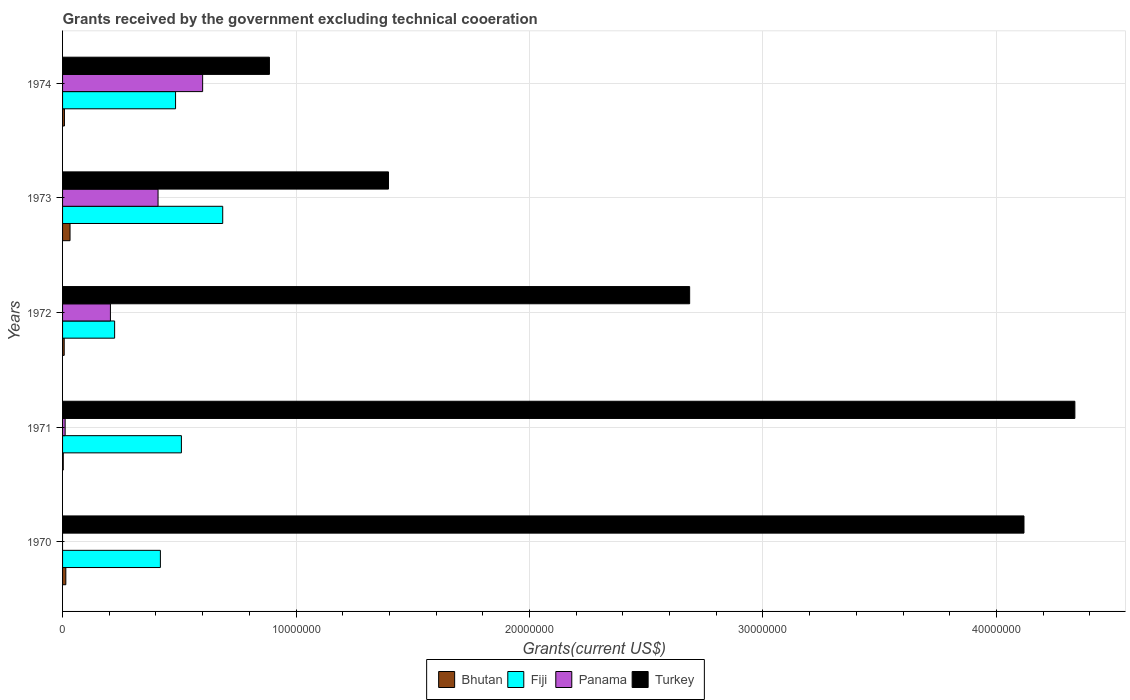How many different coloured bars are there?
Make the answer very short. 4. Are the number of bars on each tick of the Y-axis equal?
Offer a terse response. No. What is the label of the 3rd group of bars from the top?
Keep it short and to the point. 1972. What is the total grants received by the government in Panama in 1973?
Ensure brevity in your answer.  4.09e+06. Across all years, what is the maximum total grants received by the government in Bhutan?
Offer a very short reply. 3.20e+05. Across all years, what is the minimum total grants received by the government in Turkey?
Offer a very short reply. 8.86e+06. In which year was the total grants received by the government in Turkey maximum?
Your answer should be very brief. 1971. What is the total total grants received by the government in Fiji in the graph?
Your answer should be compact. 2.32e+07. What is the difference between the total grants received by the government in Turkey in 1970 and that in 1973?
Your answer should be very brief. 2.72e+07. What is the difference between the total grants received by the government in Turkey in 1970 and the total grants received by the government in Panama in 1973?
Provide a succinct answer. 3.71e+07. What is the average total grants received by the government in Turkey per year?
Give a very brief answer. 2.68e+07. In the year 1971, what is the difference between the total grants received by the government in Bhutan and total grants received by the government in Panama?
Your answer should be very brief. -8.00e+04. What is the ratio of the total grants received by the government in Turkey in 1970 to that in 1972?
Your answer should be compact. 1.53. Is the total grants received by the government in Fiji in 1973 less than that in 1974?
Offer a terse response. No. What is the difference between the highest and the second highest total grants received by the government in Panama?
Offer a terse response. 1.91e+06. What is the difference between the highest and the lowest total grants received by the government in Turkey?
Provide a succinct answer. 3.45e+07. Are all the bars in the graph horizontal?
Provide a succinct answer. Yes. What is the difference between two consecutive major ticks on the X-axis?
Your answer should be compact. 1.00e+07. How many legend labels are there?
Give a very brief answer. 4. How are the legend labels stacked?
Make the answer very short. Horizontal. What is the title of the graph?
Your response must be concise. Grants received by the government excluding technical cooeration. Does "Benin" appear as one of the legend labels in the graph?
Your answer should be compact. No. What is the label or title of the X-axis?
Make the answer very short. Grants(current US$). What is the label or title of the Y-axis?
Make the answer very short. Years. What is the Grants(current US$) in Fiji in 1970?
Your answer should be compact. 4.19e+06. What is the Grants(current US$) of Panama in 1970?
Keep it short and to the point. 0. What is the Grants(current US$) of Turkey in 1970?
Offer a terse response. 4.12e+07. What is the Grants(current US$) of Fiji in 1971?
Ensure brevity in your answer.  5.09e+06. What is the Grants(current US$) in Panama in 1971?
Keep it short and to the point. 1.10e+05. What is the Grants(current US$) in Turkey in 1971?
Your answer should be compact. 4.34e+07. What is the Grants(current US$) of Fiji in 1972?
Ensure brevity in your answer.  2.23e+06. What is the Grants(current US$) of Panama in 1972?
Give a very brief answer. 2.05e+06. What is the Grants(current US$) of Turkey in 1972?
Make the answer very short. 2.69e+07. What is the Grants(current US$) of Bhutan in 1973?
Keep it short and to the point. 3.20e+05. What is the Grants(current US$) of Fiji in 1973?
Ensure brevity in your answer.  6.86e+06. What is the Grants(current US$) of Panama in 1973?
Your answer should be compact. 4.09e+06. What is the Grants(current US$) in Turkey in 1973?
Offer a very short reply. 1.40e+07. What is the Grants(current US$) in Bhutan in 1974?
Provide a succinct answer. 8.00e+04. What is the Grants(current US$) of Fiji in 1974?
Give a very brief answer. 4.84e+06. What is the Grants(current US$) of Panama in 1974?
Give a very brief answer. 6.00e+06. What is the Grants(current US$) of Turkey in 1974?
Make the answer very short. 8.86e+06. Across all years, what is the maximum Grants(current US$) of Fiji?
Offer a very short reply. 6.86e+06. Across all years, what is the maximum Grants(current US$) of Panama?
Offer a very short reply. 6.00e+06. Across all years, what is the maximum Grants(current US$) of Turkey?
Keep it short and to the point. 4.34e+07. Across all years, what is the minimum Grants(current US$) in Fiji?
Give a very brief answer. 2.23e+06. Across all years, what is the minimum Grants(current US$) of Turkey?
Your answer should be compact. 8.86e+06. What is the total Grants(current US$) in Bhutan in the graph?
Keep it short and to the point. 6.40e+05. What is the total Grants(current US$) of Fiji in the graph?
Keep it short and to the point. 2.32e+07. What is the total Grants(current US$) of Panama in the graph?
Your response must be concise. 1.22e+07. What is the total Grants(current US$) in Turkey in the graph?
Provide a short and direct response. 1.34e+08. What is the difference between the Grants(current US$) in Fiji in 1970 and that in 1971?
Offer a terse response. -9.00e+05. What is the difference between the Grants(current US$) of Turkey in 1970 and that in 1971?
Give a very brief answer. -2.18e+06. What is the difference between the Grants(current US$) of Fiji in 1970 and that in 1972?
Your answer should be very brief. 1.96e+06. What is the difference between the Grants(current US$) of Turkey in 1970 and that in 1972?
Provide a succinct answer. 1.43e+07. What is the difference between the Grants(current US$) of Bhutan in 1970 and that in 1973?
Provide a short and direct response. -1.80e+05. What is the difference between the Grants(current US$) in Fiji in 1970 and that in 1973?
Offer a terse response. -2.67e+06. What is the difference between the Grants(current US$) in Turkey in 1970 and that in 1973?
Keep it short and to the point. 2.72e+07. What is the difference between the Grants(current US$) in Fiji in 1970 and that in 1974?
Make the answer very short. -6.50e+05. What is the difference between the Grants(current US$) in Turkey in 1970 and that in 1974?
Keep it short and to the point. 3.23e+07. What is the difference between the Grants(current US$) in Fiji in 1971 and that in 1972?
Provide a short and direct response. 2.86e+06. What is the difference between the Grants(current US$) of Panama in 1971 and that in 1972?
Keep it short and to the point. -1.94e+06. What is the difference between the Grants(current US$) in Turkey in 1971 and that in 1972?
Ensure brevity in your answer.  1.65e+07. What is the difference between the Grants(current US$) of Bhutan in 1971 and that in 1973?
Ensure brevity in your answer.  -2.90e+05. What is the difference between the Grants(current US$) of Fiji in 1971 and that in 1973?
Make the answer very short. -1.77e+06. What is the difference between the Grants(current US$) in Panama in 1971 and that in 1973?
Ensure brevity in your answer.  -3.98e+06. What is the difference between the Grants(current US$) in Turkey in 1971 and that in 1973?
Ensure brevity in your answer.  2.94e+07. What is the difference between the Grants(current US$) in Bhutan in 1971 and that in 1974?
Ensure brevity in your answer.  -5.00e+04. What is the difference between the Grants(current US$) of Panama in 1971 and that in 1974?
Ensure brevity in your answer.  -5.89e+06. What is the difference between the Grants(current US$) in Turkey in 1971 and that in 1974?
Your answer should be very brief. 3.45e+07. What is the difference between the Grants(current US$) of Bhutan in 1972 and that in 1973?
Your response must be concise. -2.50e+05. What is the difference between the Grants(current US$) of Fiji in 1972 and that in 1973?
Your response must be concise. -4.63e+06. What is the difference between the Grants(current US$) of Panama in 1972 and that in 1973?
Your answer should be compact. -2.04e+06. What is the difference between the Grants(current US$) of Turkey in 1972 and that in 1973?
Offer a very short reply. 1.29e+07. What is the difference between the Grants(current US$) in Bhutan in 1972 and that in 1974?
Your response must be concise. -10000. What is the difference between the Grants(current US$) of Fiji in 1972 and that in 1974?
Offer a very short reply. -2.61e+06. What is the difference between the Grants(current US$) of Panama in 1972 and that in 1974?
Offer a very short reply. -3.95e+06. What is the difference between the Grants(current US$) of Turkey in 1972 and that in 1974?
Keep it short and to the point. 1.80e+07. What is the difference between the Grants(current US$) in Fiji in 1973 and that in 1974?
Give a very brief answer. 2.02e+06. What is the difference between the Grants(current US$) of Panama in 1973 and that in 1974?
Make the answer very short. -1.91e+06. What is the difference between the Grants(current US$) of Turkey in 1973 and that in 1974?
Make the answer very short. 5.10e+06. What is the difference between the Grants(current US$) of Bhutan in 1970 and the Grants(current US$) of Fiji in 1971?
Offer a very short reply. -4.95e+06. What is the difference between the Grants(current US$) of Bhutan in 1970 and the Grants(current US$) of Turkey in 1971?
Offer a terse response. -4.32e+07. What is the difference between the Grants(current US$) of Fiji in 1970 and the Grants(current US$) of Panama in 1971?
Provide a short and direct response. 4.08e+06. What is the difference between the Grants(current US$) in Fiji in 1970 and the Grants(current US$) in Turkey in 1971?
Your answer should be compact. -3.92e+07. What is the difference between the Grants(current US$) of Bhutan in 1970 and the Grants(current US$) of Fiji in 1972?
Provide a short and direct response. -2.09e+06. What is the difference between the Grants(current US$) of Bhutan in 1970 and the Grants(current US$) of Panama in 1972?
Provide a succinct answer. -1.91e+06. What is the difference between the Grants(current US$) of Bhutan in 1970 and the Grants(current US$) of Turkey in 1972?
Offer a terse response. -2.67e+07. What is the difference between the Grants(current US$) in Fiji in 1970 and the Grants(current US$) in Panama in 1972?
Your answer should be very brief. 2.14e+06. What is the difference between the Grants(current US$) in Fiji in 1970 and the Grants(current US$) in Turkey in 1972?
Your response must be concise. -2.27e+07. What is the difference between the Grants(current US$) in Bhutan in 1970 and the Grants(current US$) in Fiji in 1973?
Give a very brief answer. -6.72e+06. What is the difference between the Grants(current US$) of Bhutan in 1970 and the Grants(current US$) of Panama in 1973?
Your answer should be very brief. -3.95e+06. What is the difference between the Grants(current US$) in Bhutan in 1970 and the Grants(current US$) in Turkey in 1973?
Provide a succinct answer. -1.38e+07. What is the difference between the Grants(current US$) in Fiji in 1970 and the Grants(current US$) in Panama in 1973?
Make the answer very short. 1.00e+05. What is the difference between the Grants(current US$) in Fiji in 1970 and the Grants(current US$) in Turkey in 1973?
Ensure brevity in your answer.  -9.77e+06. What is the difference between the Grants(current US$) in Bhutan in 1970 and the Grants(current US$) in Fiji in 1974?
Provide a short and direct response. -4.70e+06. What is the difference between the Grants(current US$) in Bhutan in 1970 and the Grants(current US$) in Panama in 1974?
Give a very brief answer. -5.86e+06. What is the difference between the Grants(current US$) in Bhutan in 1970 and the Grants(current US$) in Turkey in 1974?
Your answer should be compact. -8.72e+06. What is the difference between the Grants(current US$) in Fiji in 1970 and the Grants(current US$) in Panama in 1974?
Provide a succinct answer. -1.81e+06. What is the difference between the Grants(current US$) in Fiji in 1970 and the Grants(current US$) in Turkey in 1974?
Ensure brevity in your answer.  -4.67e+06. What is the difference between the Grants(current US$) in Bhutan in 1971 and the Grants(current US$) in Fiji in 1972?
Your answer should be very brief. -2.20e+06. What is the difference between the Grants(current US$) in Bhutan in 1971 and the Grants(current US$) in Panama in 1972?
Make the answer very short. -2.02e+06. What is the difference between the Grants(current US$) in Bhutan in 1971 and the Grants(current US$) in Turkey in 1972?
Make the answer very short. -2.68e+07. What is the difference between the Grants(current US$) of Fiji in 1971 and the Grants(current US$) of Panama in 1972?
Make the answer very short. 3.04e+06. What is the difference between the Grants(current US$) of Fiji in 1971 and the Grants(current US$) of Turkey in 1972?
Your answer should be compact. -2.18e+07. What is the difference between the Grants(current US$) of Panama in 1971 and the Grants(current US$) of Turkey in 1972?
Your answer should be compact. -2.68e+07. What is the difference between the Grants(current US$) in Bhutan in 1971 and the Grants(current US$) in Fiji in 1973?
Give a very brief answer. -6.83e+06. What is the difference between the Grants(current US$) in Bhutan in 1971 and the Grants(current US$) in Panama in 1973?
Offer a terse response. -4.06e+06. What is the difference between the Grants(current US$) of Bhutan in 1971 and the Grants(current US$) of Turkey in 1973?
Give a very brief answer. -1.39e+07. What is the difference between the Grants(current US$) of Fiji in 1971 and the Grants(current US$) of Panama in 1973?
Make the answer very short. 1.00e+06. What is the difference between the Grants(current US$) in Fiji in 1971 and the Grants(current US$) in Turkey in 1973?
Make the answer very short. -8.87e+06. What is the difference between the Grants(current US$) of Panama in 1971 and the Grants(current US$) of Turkey in 1973?
Give a very brief answer. -1.38e+07. What is the difference between the Grants(current US$) of Bhutan in 1971 and the Grants(current US$) of Fiji in 1974?
Your response must be concise. -4.81e+06. What is the difference between the Grants(current US$) of Bhutan in 1971 and the Grants(current US$) of Panama in 1974?
Offer a very short reply. -5.97e+06. What is the difference between the Grants(current US$) of Bhutan in 1971 and the Grants(current US$) of Turkey in 1974?
Provide a succinct answer. -8.83e+06. What is the difference between the Grants(current US$) in Fiji in 1971 and the Grants(current US$) in Panama in 1974?
Offer a terse response. -9.10e+05. What is the difference between the Grants(current US$) in Fiji in 1971 and the Grants(current US$) in Turkey in 1974?
Your answer should be very brief. -3.77e+06. What is the difference between the Grants(current US$) in Panama in 1971 and the Grants(current US$) in Turkey in 1974?
Make the answer very short. -8.75e+06. What is the difference between the Grants(current US$) in Bhutan in 1972 and the Grants(current US$) in Fiji in 1973?
Provide a short and direct response. -6.79e+06. What is the difference between the Grants(current US$) of Bhutan in 1972 and the Grants(current US$) of Panama in 1973?
Provide a short and direct response. -4.02e+06. What is the difference between the Grants(current US$) in Bhutan in 1972 and the Grants(current US$) in Turkey in 1973?
Your answer should be very brief. -1.39e+07. What is the difference between the Grants(current US$) in Fiji in 1972 and the Grants(current US$) in Panama in 1973?
Give a very brief answer. -1.86e+06. What is the difference between the Grants(current US$) in Fiji in 1972 and the Grants(current US$) in Turkey in 1973?
Provide a succinct answer. -1.17e+07. What is the difference between the Grants(current US$) of Panama in 1972 and the Grants(current US$) of Turkey in 1973?
Provide a short and direct response. -1.19e+07. What is the difference between the Grants(current US$) of Bhutan in 1972 and the Grants(current US$) of Fiji in 1974?
Provide a succinct answer. -4.77e+06. What is the difference between the Grants(current US$) of Bhutan in 1972 and the Grants(current US$) of Panama in 1974?
Offer a very short reply. -5.93e+06. What is the difference between the Grants(current US$) in Bhutan in 1972 and the Grants(current US$) in Turkey in 1974?
Offer a very short reply. -8.79e+06. What is the difference between the Grants(current US$) in Fiji in 1972 and the Grants(current US$) in Panama in 1974?
Give a very brief answer. -3.77e+06. What is the difference between the Grants(current US$) of Fiji in 1972 and the Grants(current US$) of Turkey in 1974?
Your response must be concise. -6.63e+06. What is the difference between the Grants(current US$) in Panama in 1972 and the Grants(current US$) in Turkey in 1974?
Ensure brevity in your answer.  -6.81e+06. What is the difference between the Grants(current US$) in Bhutan in 1973 and the Grants(current US$) in Fiji in 1974?
Keep it short and to the point. -4.52e+06. What is the difference between the Grants(current US$) of Bhutan in 1973 and the Grants(current US$) of Panama in 1974?
Offer a very short reply. -5.68e+06. What is the difference between the Grants(current US$) in Bhutan in 1973 and the Grants(current US$) in Turkey in 1974?
Make the answer very short. -8.54e+06. What is the difference between the Grants(current US$) in Fiji in 1973 and the Grants(current US$) in Panama in 1974?
Your answer should be very brief. 8.60e+05. What is the difference between the Grants(current US$) in Fiji in 1973 and the Grants(current US$) in Turkey in 1974?
Your answer should be compact. -2.00e+06. What is the difference between the Grants(current US$) of Panama in 1973 and the Grants(current US$) of Turkey in 1974?
Your answer should be compact. -4.77e+06. What is the average Grants(current US$) in Bhutan per year?
Ensure brevity in your answer.  1.28e+05. What is the average Grants(current US$) in Fiji per year?
Ensure brevity in your answer.  4.64e+06. What is the average Grants(current US$) in Panama per year?
Your answer should be very brief. 2.45e+06. What is the average Grants(current US$) in Turkey per year?
Your response must be concise. 2.68e+07. In the year 1970, what is the difference between the Grants(current US$) in Bhutan and Grants(current US$) in Fiji?
Your response must be concise. -4.05e+06. In the year 1970, what is the difference between the Grants(current US$) of Bhutan and Grants(current US$) of Turkey?
Ensure brevity in your answer.  -4.10e+07. In the year 1970, what is the difference between the Grants(current US$) of Fiji and Grants(current US$) of Turkey?
Offer a terse response. -3.70e+07. In the year 1971, what is the difference between the Grants(current US$) of Bhutan and Grants(current US$) of Fiji?
Provide a short and direct response. -5.06e+06. In the year 1971, what is the difference between the Grants(current US$) in Bhutan and Grants(current US$) in Turkey?
Provide a succinct answer. -4.33e+07. In the year 1971, what is the difference between the Grants(current US$) of Fiji and Grants(current US$) of Panama?
Provide a short and direct response. 4.98e+06. In the year 1971, what is the difference between the Grants(current US$) of Fiji and Grants(current US$) of Turkey?
Offer a very short reply. -3.83e+07. In the year 1971, what is the difference between the Grants(current US$) of Panama and Grants(current US$) of Turkey?
Give a very brief answer. -4.32e+07. In the year 1972, what is the difference between the Grants(current US$) of Bhutan and Grants(current US$) of Fiji?
Offer a very short reply. -2.16e+06. In the year 1972, what is the difference between the Grants(current US$) of Bhutan and Grants(current US$) of Panama?
Ensure brevity in your answer.  -1.98e+06. In the year 1972, what is the difference between the Grants(current US$) in Bhutan and Grants(current US$) in Turkey?
Provide a succinct answer. -2.68e+07. In the year 1972, what is the difference between the Grants(current US$) in Fiji and Grants(current US$) in Panama?
Offer a terse response. 1.80e+05. In the year 1972, what is the difference between the Grants(current US$) in Fiji and Grants(current US$) in Turkey?
Your answer should be very brief. -2.46e+07. In the year 1972, what is the difference between the Grants(current US$) of Panama and Grants(current US$) of Turkey?
Your answer should be very brief. -2.48e+07. In the year 1973, what is the difference between the Grants(current US$) in Bhutan and Grants(current US$) in Fiji?
Your response must be concise. -6.54e+06. In the year 1973, what is the difference between the Grants(current US$) in Bhutan and Grants(current US$) in Panama?
Offer a terse response. -3.77e+06. In the year 1973, what is the difference between the Grants(current US$) in Bhutan and Grants(current US$) in Turkey?
Offer a terse response. -1.36e+07. In the year 1973, what is the difference between the Grants(current US$) of Fiji and Grants(current US$) of Panama?
Your answer should be very brief. 2.77e+06. In the year 1973, what is the difference between the Grants(current US$) of Fiji and Grants(current US$) of Turkey?
Your answer should be compact. -7.10e+06. In the year 1973, what is the difference between the Grants(current US$) of Panama and Grants(current US$) of Turkey?
Give a very brief answer. -9.87e+06. In the year 1974, what is the difference between the Grants(current US$) in Bhutan and Grants(current US$) in Fiji?
Ensure brevity in your answer.  -4.76e+06. In the year 1974, what is the difference between the Grants(current US$) in Bhutan and Grants(current US$) in Panama?
Your answer should be very brief. -5.92e+06. In the year 1974, what is the difference between the Grants(current US$) in Bhutan and Grants(current US$) in Turkey?
Ensure brevity in your answer.  -8.78e+06. In the year 1974, what is the difference between the Grants(current US$) in Fiji and Grants(current US$) in Panama?
Give a very brief answer. -1.16e+06. In the year 1974, what is the difference between the Grants(current US$) of Fiji and Grants(current US$) of Turkey?
Your answer should be very brief. -4.02e+06. In the year 1974, what is the difference between the Grants(current US$) in Panama and Grants(current US$) in Turkey?
Offer a terse response. -2.86e+06. What is the ratio of the Grants(current US$) in Bhutan in 1970 to that in 1971?
Give a very brief answer. 4.67. What is the ratio of the Grants(current US$) of Fiji in 1970 to that in 1971?
Your response must be concise. 0.82. What is the ratio of the Grants(current US$) of Turkey in 1970 to that in 1971?
Provide a short and direct response. 0.95. What is the ratio of the Grants(current US$) in Fiji in 1970 to that in 1972?
Provide a succinct answer. 1.88. What is the ratio of the Grants(current US$) in Turkey in 1970 to that in 1972?
Offer a terse response. 1.53. What is the ratio of the Grants(current US$) in Bhutan in 1970 to that in 1973?
Offer a very short reply. 0.44. What is the ratio of the Grants(current US$) in Fiji in 1970 to that in 1973?
Make the answer very short. 0.61. What is the ratio of the Grants(current US$) in Turkey in 1970 to that in 1973?
Offer a terse response. 2.95. What is the ratio of the Grants(current US$) of Fiji in 1970 to that in 1974?
Make the answer very short. 0.87. What is the ratio of the Grants(current US$) of Turkey in 1970 to that in 1974?
Provide a short and direct response. 4.65. What is the ratio of the Grants(current US$) in Bhutan in 1971 to that in 1972?
Give a very brief answer. 0.43. What is the ratio of the Grants(current US$) in Fiji in 1971 to that in 1972?
Keep it short and to the point. 2.28. What is the ratio of the Grants(current US$) of Panama in 1971 to that in 1972?
Ensure brevity in your answer.  0.05. What is the ratio of the Grants(current US$) in Turkey in 1971 to that in 1972?
Provide a succinct answer. 1.61. What is the ratio of the Grants(current US$) in Bhutan in 1971 to that in 1973?
Make the answer very short. 0.09. What is the ratio of the Grants(current US$) of Fiji in 1971 to that in 1973?
Provide a succinct answer. 0.74. What is the ratio of the Grants(current US$) in Panama in 1971 to that in 1973?
Offer a very short reply. 0.03. What is the ratio of the Grants(current US$) of Turkey in 1971 to that in 1973?
Give a very brief answer. 3.11. What is the ratio of the Grants(current US$) of Bhutan in 1971 to that in 1974?
Provide a short and direct response. 0.38. What is the ratio of the Grants(current US$) in Fiji in 1971 to that in 1974?
Provide a succinct answer. 1.05. What is the ratio of the Grants(current US$) in Panama in 1971 to that in 1974?
Provide a succinct answer. 0.02. What is the ratio of the Grants(current US$) of Turkey in 1971 to that in 1974?
Provide a succinct answer. 4.89. What is the ratio of the Grants(current US$) in Bhutan in 1972 to that in 1973?
Provide a short and direct response. 0.22. What is the ratio of the Grants(current US$) of Fiji in 1972 to that in 1973?
Your response must be concise. 0.33. What is the ratio of the Grants(current US$) in Panama in 1972 to that in 1973?
Keep it short and to the point. 0.5. What is the ratio of the Grants(current US$) of Turkey in 1972 to that in 1973?
Your response must be concise. 1.92. What is the ratio of the Grants(current US$) in Bhutan in 1972 to that in 1974?
Offer a very short reply. 0.88. What is the ratio of the Grants(current US$) in Fiji in 1972 to that in 1974?
Offer a terse response. 0.46. What is the ratio of the Grants(current US$) in Panama in 1972 to that in 1974?
Provide a succinct answer. 0.34. What is the ratio of the Grants(current US$) of Turkey in 1972 to that in 1974?
Offer a very short reply. 3.03. What is the ratio of the Grants(current US$) in Bhutan in 1973 to that in 1974?
Offer a very short reply. 4. What is the ratio of the Grants(current US$) in Fiji in 1973 to that in 1974?
Ensure brevity in your answer.  1.42. What is the ratio of the Grants(current US$) of Panama in 1973 to that in 1974?
Your answer should be compact. 0.68. What is the ratio of the Grants(current US$) in Turkey in 1973 to that in 1974?
Give a very brief answer. 1.58. What is the difference between the highest and the second highest Grants(current US$) of Fiji?
Offer a very short reply. 1.77e+06. What is the difference between the highest and the second highest Grants(current US$) in Panama?
Ensure brevity in your answer.  1.91e+06. What is the difference between the highest and the second highest Grants(current US$) of Turkey?
Provide a short and direct response. 2.18e+06. What is the difference between the highest and the lowest Grants(current US$) in Fiji?
Offer a very short reply. 4.63e+06. What is the difference between the highest and the lowest Grants(current US$) of Turkey?
Provide a short and direct response. 3.45e+07. 